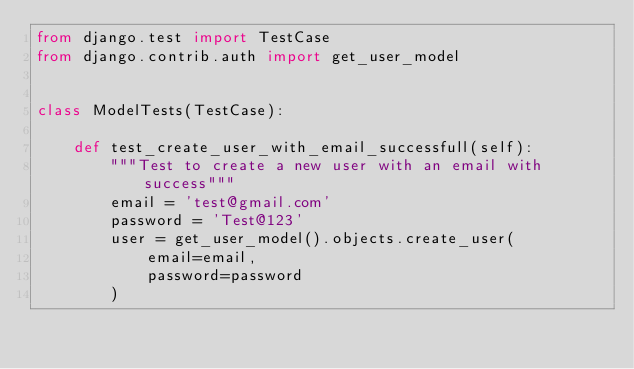Convert code to text. <code><loc_0><loc_0><loc_500><loc_500><_Python_>from django.test import TestCase
from django.contrib.auth import get_user_model


class ModelTests(TestCase):

    def test_create_user_with_email_successfull(self):
        """Test to create a new user with an email with success"""
        email = 'test@gmail.com'
        password = 'Test@123'
        user = get_user_model().objects.create_user(
            email=email,
            password=password
        )
</code> 